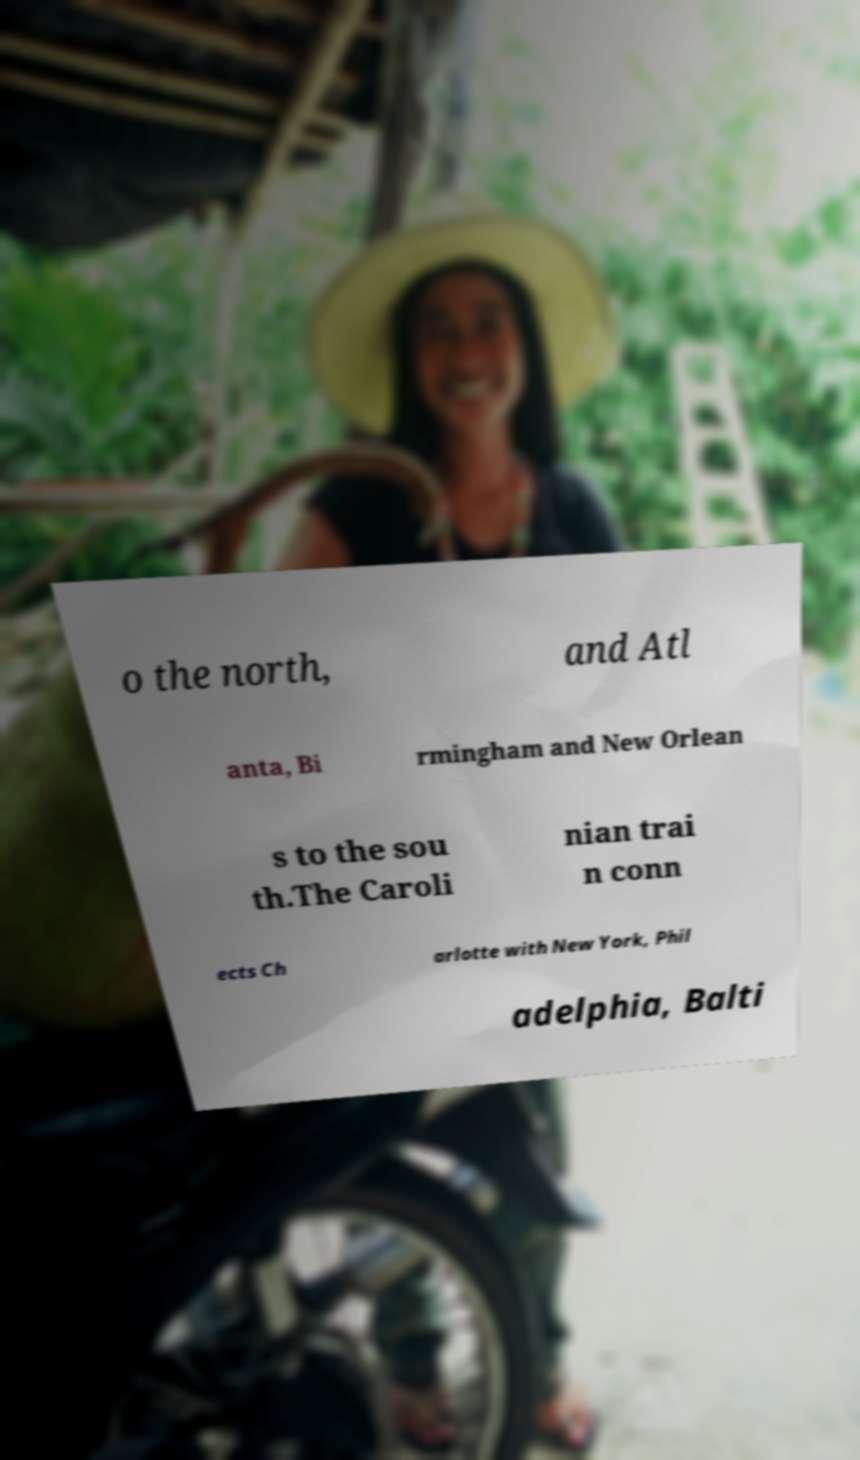Please identify and transcribe the text found in this image. o the north, and Atl anta, Bi rmingham and New Orlean s to the sou th.The Caroli nian trai n conn ects Ch arlotte with New York, Phil adelphia, Balti 